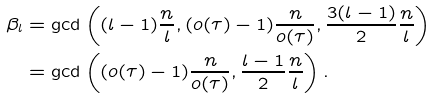Convert formula to latex. <formula><loc_0><loc_0><loc_500><loc_500>\beta _ { l } & = \gcd \left ( ( l - 1 ) \frac { n } { l } , ( o ( \tau ) - 1 ) \frac { n } { o ( \tau ) } , \frac { 3 ( l - 1 ) } { 2 } \frac { n } { l } \right ) \\ & = \gcd \left ( ( o ( \tau ) - 1 ) \frac { n } { o ( \tau ) } , \frac { l - 1 } { 2 } \frac { n } { l } \right ) .</formula> 